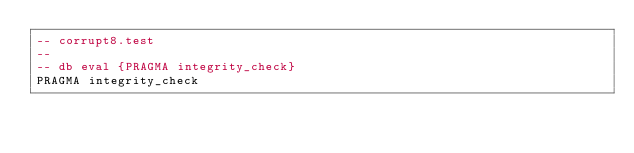Convert code to text. <code><loc_0><loc_0><loc_500><loc_500><_SQL_>-- corrupt8.test
-- 
-- db eval {PRAGMA integrity_check}
PRAGMA integrity_check</code> 